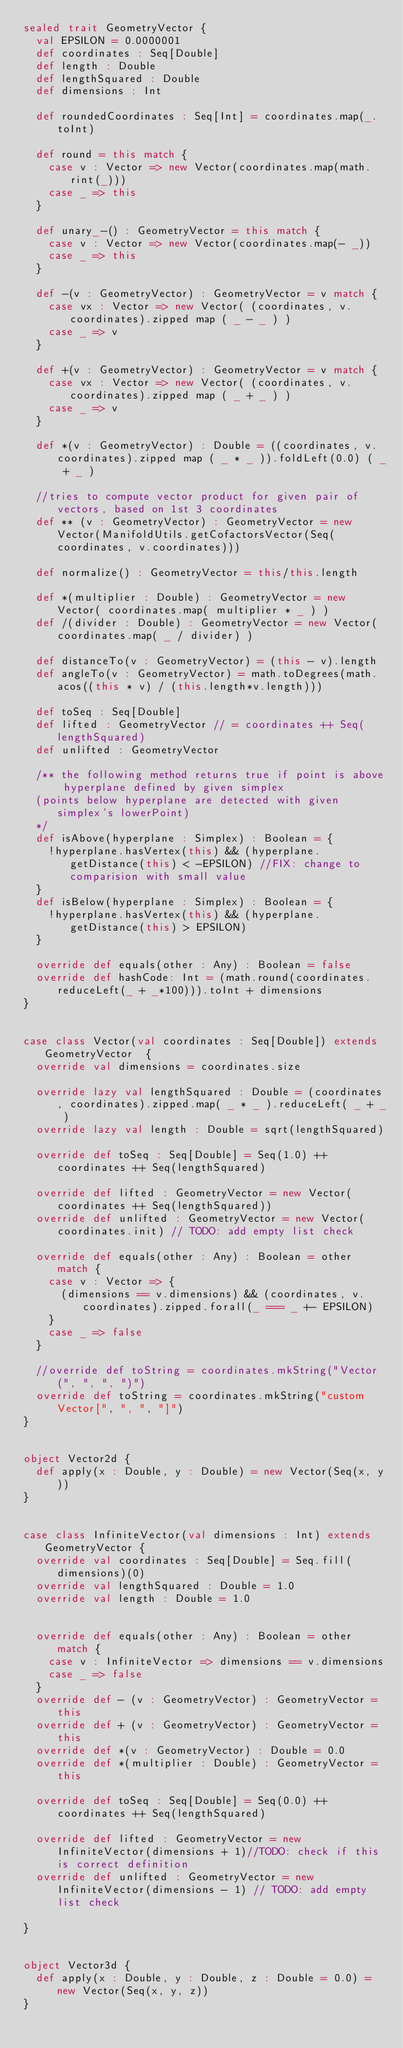<code> <loc_0><loc_0><loc_500><loc_500><_Scala_>sealed trait GeometryVector {
  val EPSILON = 0.0000001
  def coordinates : Seq[Double]
  def length : Double
  def lengthSquared : Double
  def dimensions : Int

  def roundedCoordinates : Seq[Int] = coordinates.map(_.toInt)

  def round = this match {
    case v : Vector => new Vector(coordinates.map(math.rint(_)))
    case _ => this
  }

  def unary_-() : GeometryVector = this match {
    case v : Vector => new Vector(coordinates.map(- _))
    case _ => this
  }

  def -(v : GeometryVector) : GeometryVector = v match {
    case vx : Vector => new Vector( (coordinates, v.coordinates).zipped map ( _ - _ ) )
    case _ => v
  }

  def +(v : GeometryVector) : GeometryVector = v match {
    case vx : Vector => new Vector( (coordinates, v.coordinates).zipped map ( _ + _ ) )
    case _ => v
  }

  def *(v : GeometryVector) : Double = ((coordinates, v.coordinates).zipped map ( _ * _ )).foldLeft(0.0) ( _ + _ )

  //tries to compute vector product for given pair of vectors, based on 1st 3 coordinates
  def ** (v : GeometryVector) : GeometryVector = new Vector(ManifoldUtils.getCofactorsVector(Seq(coordinates, v.coordinates)))

  def normalize() : GeometryVector = this/this.length

  def *(multiplier : Double) : GeometryVector = new Vector( coordinates.map( multiplier * _ ) )
  def /(divider : Double) : GeometryVector = new Vector( coordinates.map( _ / divider) )

  def distanceTo(v : GeometryVector) = (this - v).length
  def angleTo(v : GeometryVector) = math.toDegrees(math.acos((this * v) / (this.length*v.length)))

  def toSeq : Seq[Double]
  def lifted : GeometryVector // = coordinates ++ Seq(lengthSquared)
  def unlifted : GeometryVector

  /** the following method returns true if point is above hyperplane defined by given simplex
  (points below hyperplane are detected with given simplex's lowerPoint)
  */
  def isAbove(hyperplane : Simplex) : Boolean = {
    !hyperplane.hasVertex(this) && (hyperplane.getDistance(this) < -EPSILON) //FIX: change to comparision with small value
  }
  def isBelow(hyperplane : Simplex) : Boolean = {
    !hyperplane.hasVertex(this) && (hyperplane.getDistance(this) > EPSILON)
  }

  override def equals(other : Any) : Boolean = false
  override def hashCode: Int = (math.round(coordinates.reduceLeft(_ + _*100))).toInt + dimensions
}


case class Vector(val coordinates : Seq[Double]) extends GeometryVector  {
  override val dimensions = coordinates.size

  override lazy val lengthSquared : Double = (coordinates, coordinates).zipped.map( _ * _ ).reduceLeft( _ + _ )
  override lazy val length : Double = sqrt(lengthSquared)

  override def toSeq : Seq[Double] = Seq(1.0) ++ coordinates ++ Seq(lengthSquared)

  override def lifted : GeometryVector = new Vector(coordinates ++ Seq(lengthSquared))
  override def unlifted : GeometryVector = new Vector(coordinates.init) // TODO: add empty list check

  override def equals(other : Any) : Boolean = other match {
    case v : Vector => {
      (dimensions == v.dimensions) && (coordinates, v.coordinates).zipped.forall(_ === _ +- EPSILON)
    }
    case _ => false
  }

  //override def toString = coordinates.mkString("Vector (", ", ", ")")
  override def toString = coordinates.mkString("custom Vector[", ", ", "]")
}


object Vector2d {
  def apply(x : Double, y : Double) = new Vector(Seq(x, y))
}


case class InfiniteVector(val dimensions : Int) extends GeometryVector {
  override val coordinates : Seq[Double] = Seq.fill(dimensions)(0)
  override val lengthSquared : Double = 1.0
  override val length : Double = 1.0


  override def equals(other : Any) : Boolean = other match {
    case v : InfiniteVector => dimensions == v.dimensions
    case _ => false
  }
  override def - (v : GeometryVector) : GeometryVector = this
  override def + (v : GeometryVector) : GeometryVector = this
  override def *(v : GeometryVector) : Double = 0.0
  override def *(multiplier : Double) : GeometryVector = this

  override def toSeq : Seq[Double] = Seq(0.0) ++ coordinates ++ Seq(lengthSquared)

  override def lifted : GeometryVector = new InfiniteVector(dimensions + 1)//TODO: check if this is correct definition
  override def unlifted : GeometryVector = new InfiniteVector(dimensions - 1) // TODO: add empty list check

}


object Vector3d {
  def apply(x : Double, y : Double, z : Double = 0.0) = new Vector(Seq(x, y, z))
}
</code> 